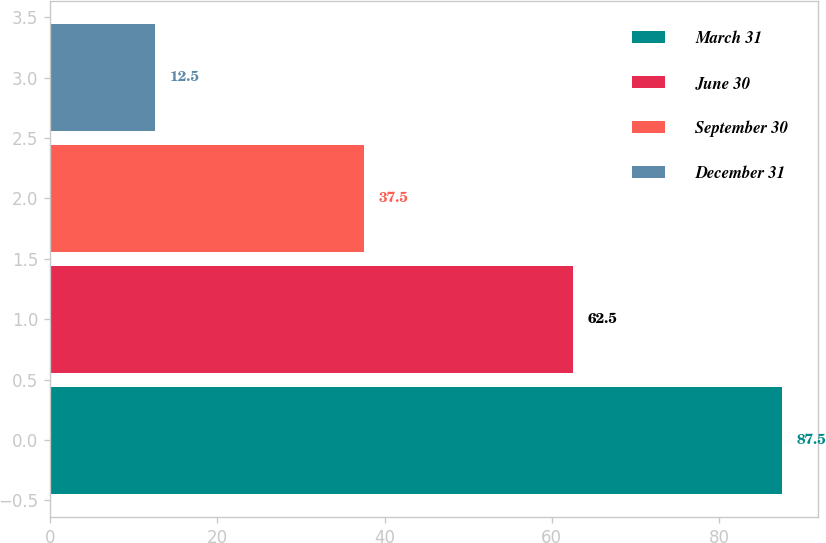Convert chart to OTSL. <chart><loc_0><loc_0><loc_500><loc_500><bar_chart><fcel>March 31<fcel>June 30<fcel>September 30<fcel>December 31<nl><fcel>87.5<fcel>62.5<fcel>37.5<fcel>12.5<nl></chart> 